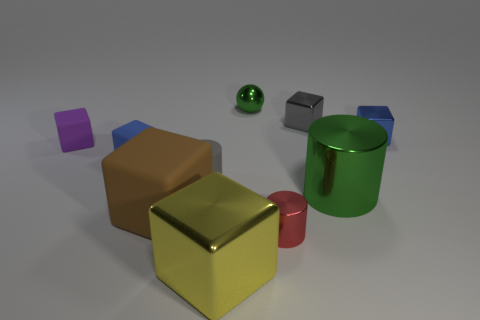How many small blue shiny things are on the left side of the matte object that is to the right of the big brown matte block?
Your response must be concise. 0. Are there any other things that are made of the same material as the large green object?
Make the answer very short. Yes. What material is the tiny blue cube right of the blue block in front of the small blue thing that is behind the purple object made of?
Give a very brief answer. Metal. There is a thing that is both left of the red metallic cylinder and in front of the large brown rubber cube; what material is it?
Offer a terse response. Metal. What number of small cyan objects are the same shape as the purple rubber thing?
Provide a short and direct response. 0. There is a brown matte cube that is in front of the large thing on the right side of the tiny green metal object; what is its size?
Offer a very short reply. Large. There is a tiny shiny sphere that is right of the small gray cylinder; does it have the same color as the shiny cylinder on the right side of the red thing?
Give a very brief answer. Yes. What number of gray cylinders are behind the purple rubber block on the left side of the large metal object that is in front of the big brown object?
Ensure brevity in your answer.  0. What number of blocks are behind the green metal cylinder and on the right side of the brown rubber object?
Offer a very short reply. 2. Is the number of gray blocks right of the big brown thing greater than the number of red matte blocks?
Ensure brevity in your answer.  Yes. 